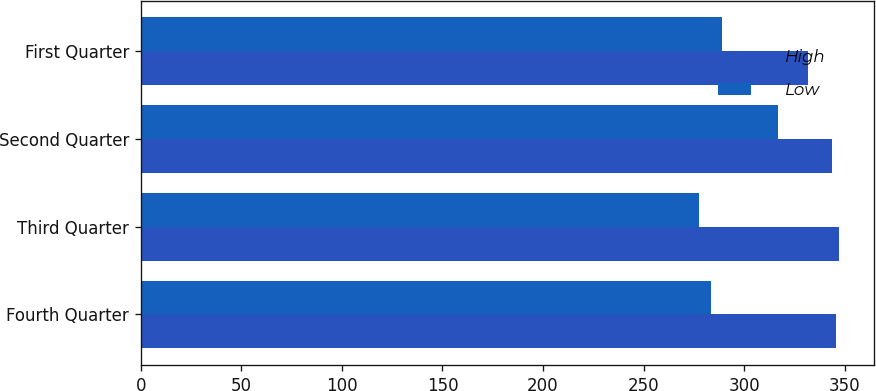Convert chart. <chart><loc_0><loc_0><loc_500><loc_500><stacked_bar_chart><ecel><fcel>Fourth Quarter<fcel>Third Quarter<fcel>Second Quarter<fcel>First Quarter<nl><fcel>High<fcel>345.75<fcel>346.92<fcel>343.44<fcel>331.84<nl><fcel>Low<fcel>283.27<fcel>277.62<fcel>317.01<fcel>289.09<nl></chart> 